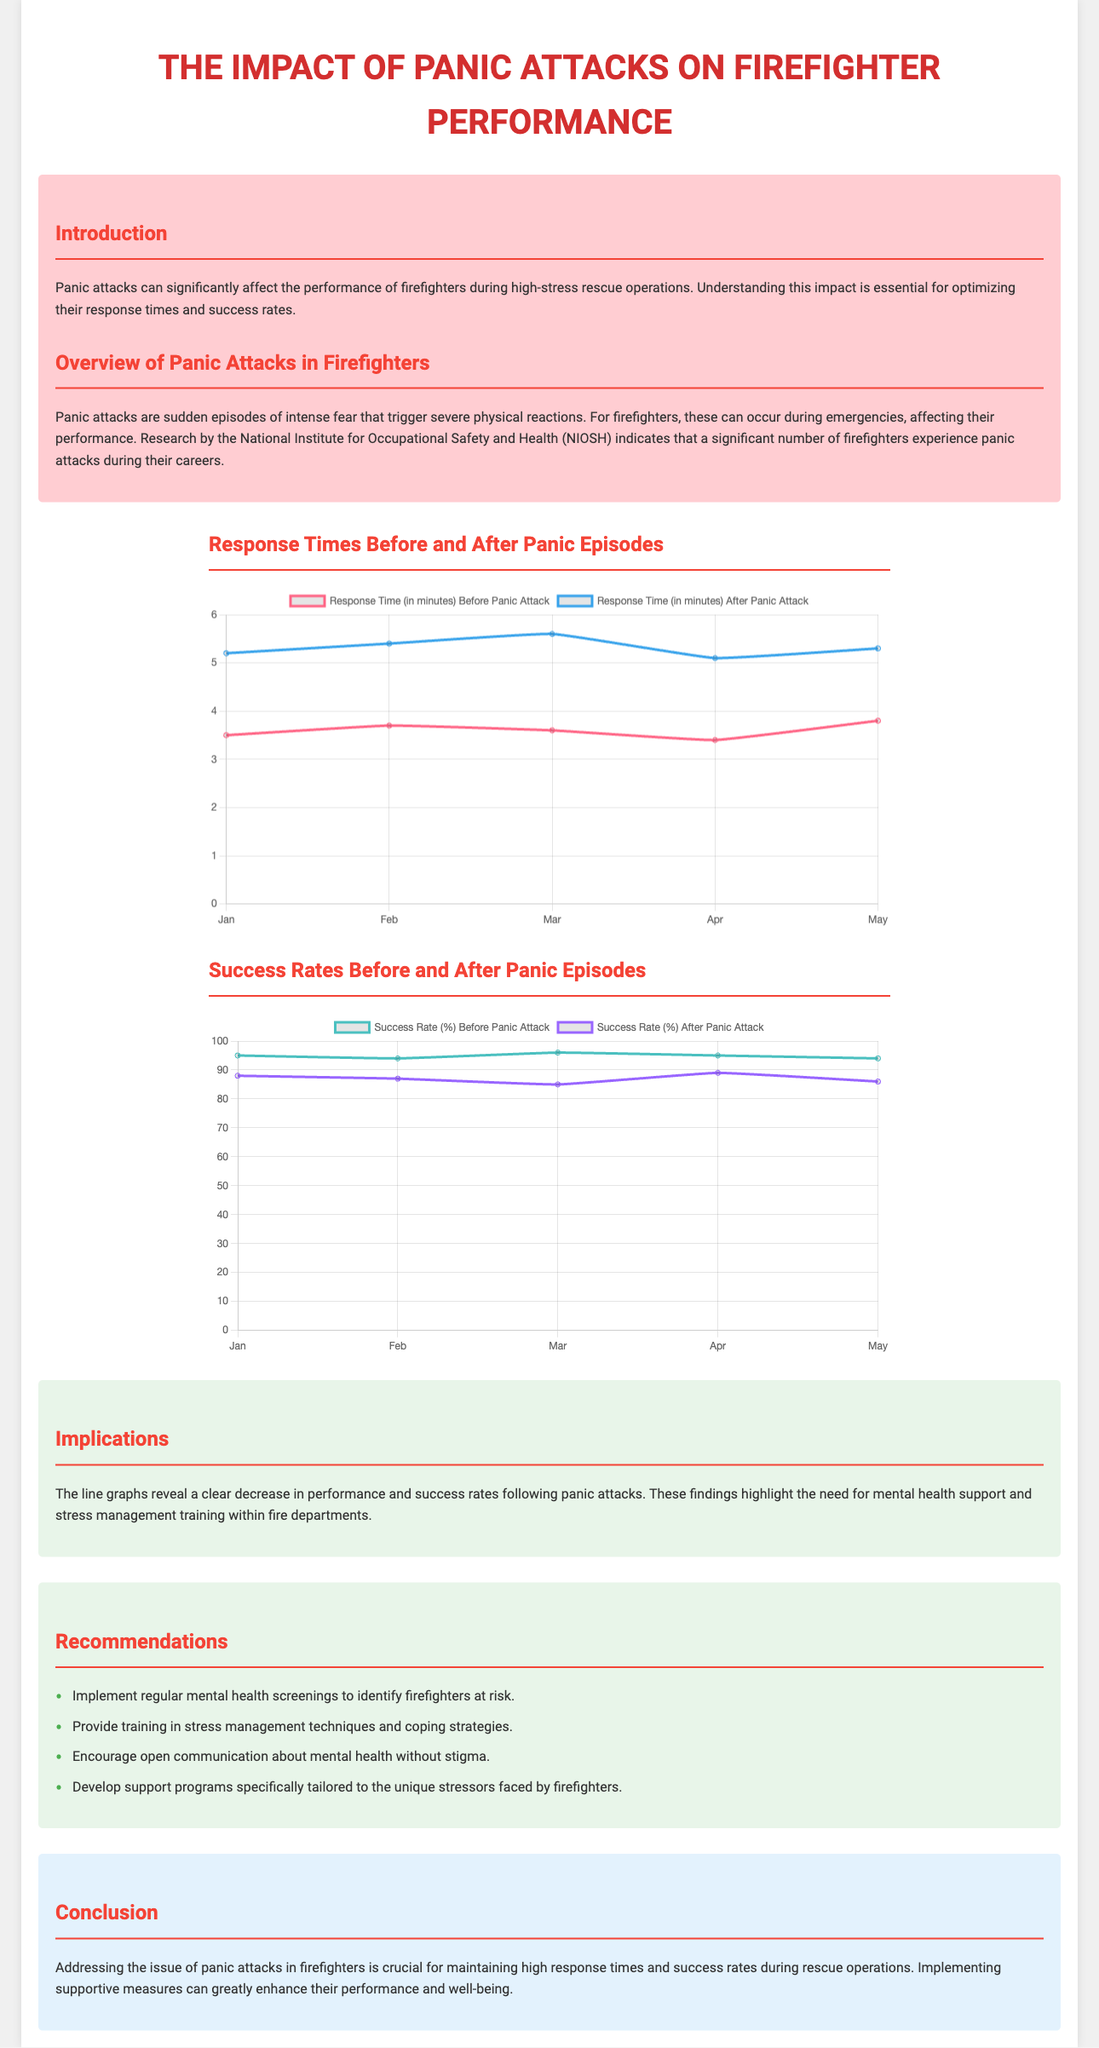What is the primary focus of the infographic? The infographic focuses on the impact of panic attacks on firefighter performance, particularly response times and success rates.
Answer: Impact of panic attacks on firefighter performance What is the average response time before a panic attack in April? The average response time before a panic attack in April is shown as 3.4 minutes on the line graph.
Answer: 3.4 minutes What does the success rate drop to after a panic attack in February? The success rate after a panic attack in February drops to 87%, as indicated in the success rate chart.
Answer: 87% What color represents the response times after panic attacks? The response times after panic attacks are represented by the color blue in the graph.
Answer: Blue How many recommendations are provided in the infographic? The infographic includes four specific recommendations to address the issue of panic attacks in firefighters.
Answer: Four What is the significance of the findings presented in the implications section? The findings indicate a decrease in performance and success rates following panic attacks, highlighting the need for mental health support.
Answer: Decrease in performance and success rates What trend is observed in success rates before panic attacks from January to May? The trend in success rates before panic attacks shows slight fluctuations but remains relatively stable around the 94% to 96% range.
Answer: Relatively stable What is the background color of the implications section? The background color of the implications section is light green, as noted in the document's styling.
Answer: Light green 